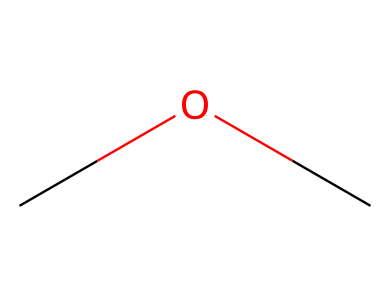What is the name of this chemical? The SMILES notation 'COC' represents a simple ether. The molecular structure contains an oxygen atom (O) bonded to two carbon groups (C) that are themselves bonded to hydrogen atoms. The common name for this specific ether is dimethyl ether.
Answer: dimethyl ether How many carbon atoms are in this molecule? Looking at the SMILES 'COC', there are two carbon atoms represented by the 'C' characters on both ends of the molecule. Each lead to a methyl group (CH3), confirming that there are indeed two carbons.
Answer: two What type of functional group is present in this compound? The presence of the oxygen atom (O) connected to two alkyl groups signifies the presence of an ether functional group. This is characteristic of ethers, which is confirmed by the naming and structure.
Answer: ether What is the relationship of the carbon atoms to the oxygen atom? In dimethyl ether, each carbon atom (C) is directly connected to the oxygen atom (O) through a single bond. This indicates that both carbon atoms are bonded to the same oxygen atom, giving it the characteristic ether structure.
Answer: bonded How many hydrogen atoms are attached to the carbon atoms? Each carbon in the structure is a methyl group (CH3), indicating that there are three hydrogen atoms attached to each carbon. Since there are two carbon atoms, that results in a total of six hydrogen atoms in the molecule.
Answer: six What is a primary use of dimethyl ether in aerosol applications? Dimethyl ether is often used as a propellant in aerosol formulations due to its favorable properties, including low toxicity and a suitable boiling point. This makes it ideal for dispersing substances in aerosol forms efficiently.
Answer: propellant What is the solubility characteristic of dimethyl ether? Dimethyl ether is known to be soluble in water due to its polar nature from the ether functional group. The oxygen atom allows the molecule to interact with water molecules, enhancing its solubility.
Answer: soluble 